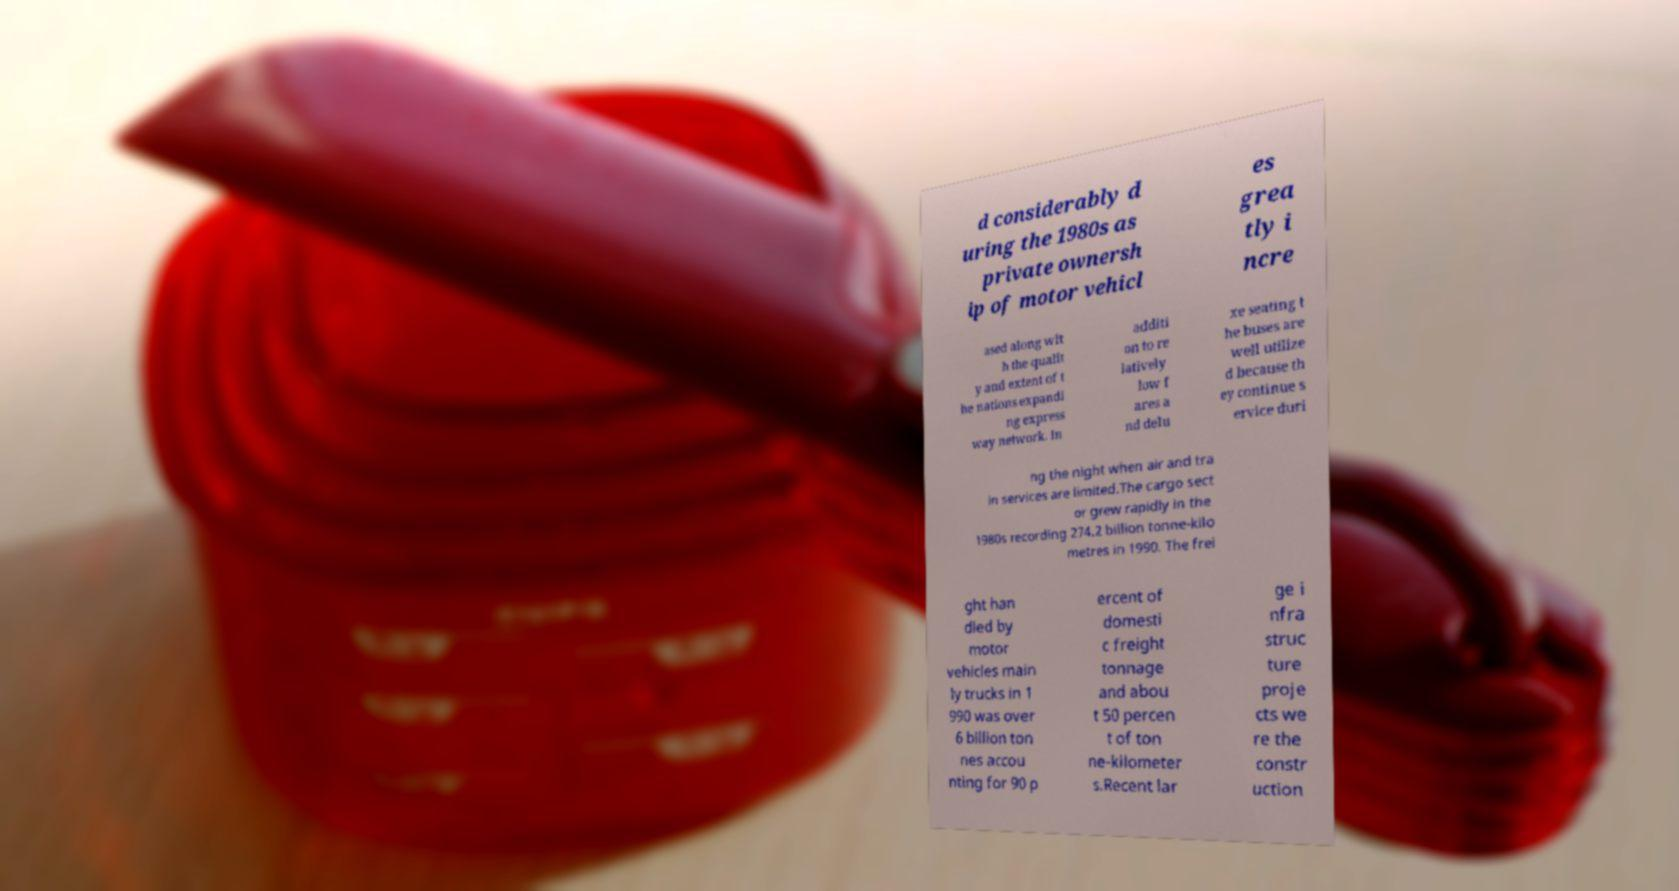I need the written content from this picture converted into text. Can you do that? d considerably d uring the 1980s as private ownersh ip of motor vehicl es grea tly i ncre ased along wit h the qualit y and extent of t he nations expandi ng express way network. In additi on to re latively low f ares a nd delu xe seating t he buses are well utilize d because th ey continue s ervice duri ng the night when air and tra in services are limited.The cargo sect or grew rapidly in the 1980s recording 274.2 billion tonne-kilo metres in 1990. The frei ght han dled by motor vehicles main ly trucks in 1 990 was over 6 billion ton nes accou nting for 90 p ercent of domesti c freight tonnage and abou t 50 percen t of ton ne-kilometer s.Recent lar ge i nfra struc ture proje cts we re the constr uction 